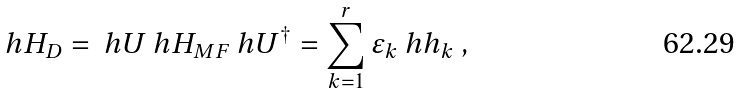Convert formula to latex. <formula><loc_0><loc_0><loc_500><loc_500>\ h H _ { D } = \ h U \ h H _ { M F } \ h U ^ { \dagger } = \sum _ { k = 1 } ^ { r } \varepsilon _ { k } \ h h _ { k } \ ,</formula> 